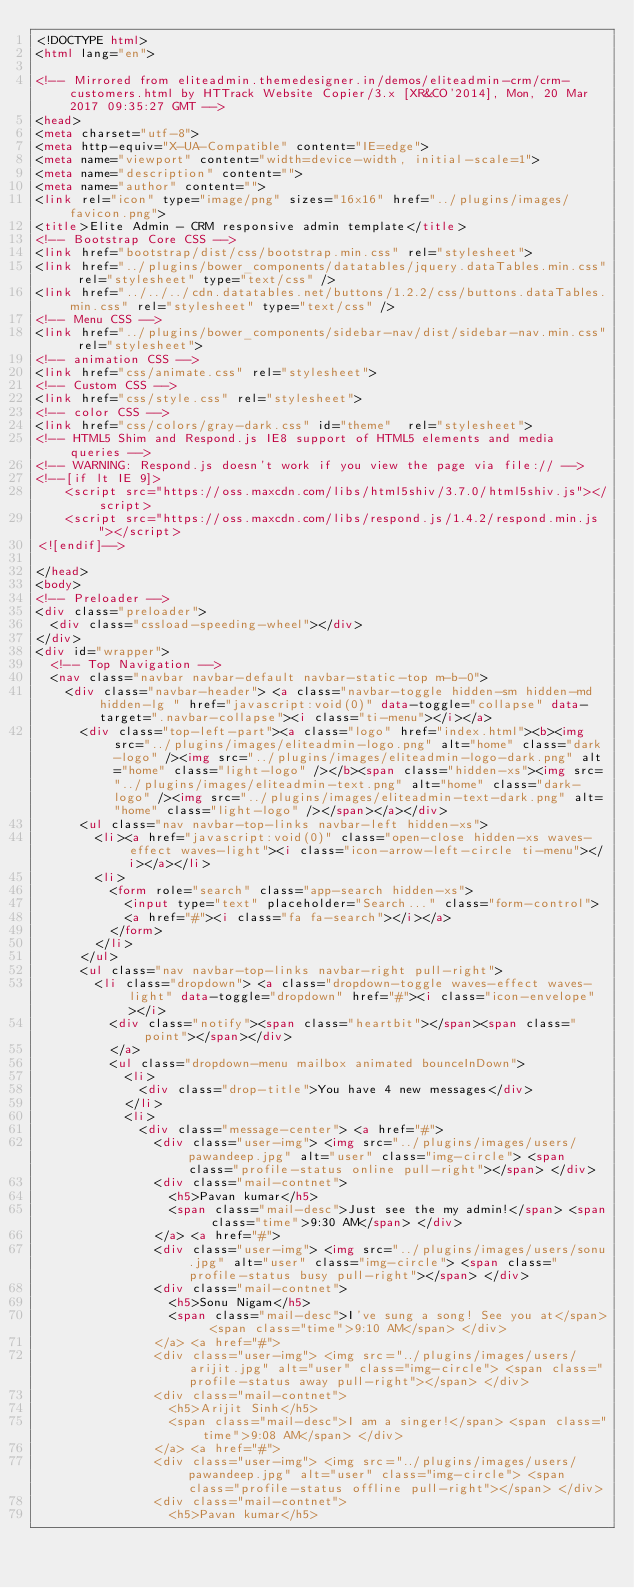Convert code to text. <code><loc_0><loc_0><loc_500><loc_500><_HTML_><!DOCTYPE html>  
<html lang="en">

<!-- Mirrored from eliteadmin.themedesigner.in/demos/eliteadmin-crm/crm-customers.html by HTTrack Website Copier/3.x [XR&CO'2014], Mon, 20 Mar 2017 09:35:27 GMT -->
<head>
<meta charset="utf-8">
<meta http-equiv="X-UA-Compatible" content="IE=edge">
<meta name="viewport" content="width=device-width, initial-scale=1">
<meta name="description" content="">
<meta name="author" content="">
<link rel="icon" type="image/png" sizes="16x16" href="../plugins/images/favicon.png">
<title>Elite Admin - CRM responsive admin template</title>
<!-- Bootstrap Core CSS -->
<link href="bootstrap/dist/css/bootstrap.min.css" rel="stylesheet">
<link href="../plugins/bower_components/datatables/jquery.dataTables.min.css" rel="stylesheet" type="text/css" />
<link href="../../../cdn.datatables.net/buttons/1.2.2/css/buttons.dataTables.min.css" rel="stylesheet" type="text/css" />
<!-- Menu CSS -->
<link href="../plugins/bower_components/sidebar-nav/dist/sidebar-nav.min.css" rel="stylesheet">
<!-- animation CSS -->
<link href="css/animate.css" rel="stylesheet">
<!-- Custom CSS -->
<link href="css/style.css" rel="stylesheet">
<!-- color CSS -->
<link href="css/colors/gray-dark.css" id="theme"  rel="stylesheet">
<!-- HTML5 Shim and Respond.js IE8 support of HTML5 elements and media queries -->
<!-- WARNING: Respond.js doesn't work if you view the page via file:// -->
<!--[if lt IE 9]>
    <script src="https://oss.maxcdn.com/libs/html5shiv/3.7.0/html5shiv.js"></script>
    <script src="https://oss.maxcdn.com/libs/respond.js/1.4.2/respond.min.js"></script>
<![endif]-->

</head>
<body>
<!-- Preloader -->
<div class="preloader">
  <div class="cssload-speeding-wheel"></div>
</div>
<div id="wrapper">
  <!-- Top Navigation -->
  <nav class="navbar navbar-default navbar-static-top m-b-0">
    <div class="navbar-header"> <a class="navbar-toggle hidden-sm hidden-md hidden-lg " href="javascript:void(0)" data-toggle="collapse" data-target=".navbar-collapse"><i class="ti-menu"></i></a>
      <div class="top-left-part"><a class="logo" href="index.html"><b><img src="../plugins/images/eliteadmin-logo.png" alt="home" class="dark-logo" /><img src="../plugins/images/eliteadmin-logo-dark.png" alt="home" class="light-logo" /></b><span class="hidden-xs"><img src="../plugins/images/eliteadmin-text.png" alt="home" class="dark-logo" /><img src="../plugins/images/eliteadmin-text-dark.png" alt="home" class="light-logo" /></span></a></div>
      <ul class="nav navbar-top-links navbar-left hidden-xs">
        <li><a href="javascript:void(0)" class="open-close hidden-xs waves-effect waves-light"><i class="icon-arrow-left-circle ti-menu"></i></a></li>
        <li>
          <form role="search" class="app-search hidden-xs">
            <input type="text" placeholder="Search..." class="form-control">
            <a href="#"><i class="fa fa-search"></i></a>
          </form>
        </li>
      </ul>
      <ul class="nav navbar-top-links navbar-right pull-right">
        <li class="dropdown"> <a class="dropdown-toggle waves-effect waves-light" data-toggle="dropdown" href="#"><i class="icon-envelope"></i>
          <div class="notify"><span class="heartbit"></span><span class="point"></span></div>
          </a>
          <ul class="dropdown-menu mailbox animated bounceInDown">
            <li>
              <div class="drop-title">You have 4 new messages</div>
            </li>
            <li>
              <div class="message-center"> <a href="#">
                <div class="user-img"> <img src="../plugins/images/users/pawandeep.jpg" alt="user" class="img-circle"> <span class="profile-status online pull-right"></span> </div>
                <div class="mail-contnet">
                  <h5>Pavan kumar</h5>
                  <span class="mail-desc">Just see the my admin!</span> <span class="time">9:30 AM</span> </div>
                </a> <a href="#">
                <div class="user-img"> <img src="../plugins/images/users/sonu.jpg" alt="user" class="img-circle"> <span class="profile-status busy pull-right"></span> </div>
                <div class="mail-contnet">
                  <h5>Sonu Nigam</h5>
                  <span class="mail-desc">I've sung a song! See you at</span> <span class="time">9:10 AM</span> </div>
                </a> <a href="#">
                <div class="user-img"> <img src="../plugins/images/users/arijit.jpg" alt="user" class="img-circle"> <span class="profile-status away pull-right"></span> </div>
                <div class="mail-contnet">
                  <h5>Arijit Sinh</h5>
                  <span class="mail-desc">I am a singer!</span> <span class="time">9:08 AM</span> </div>
                </a> <a href="#">
                <div class="user-img"> <img src="../plugins/images/users/pawandeep.jpg" alt="user" class="img-circle"> <span class="profile-status offline pull-right"></span> </div>
                <div class="mail-contnet">
                  <h5>Pavan kumar</h5></code> 